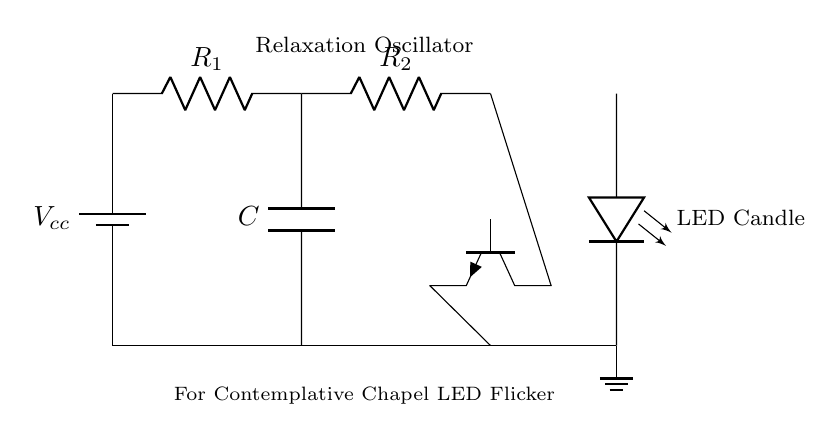What type of oscillator is depicted in the circuit? The circuit is a relaxation oscillator, which commonly uses a capacitor and a transistor to generate a non-sinusoidal waveform for effects like flickering.
Answer: relaxation oscillator What is the main purpose of this circuit in the chapel? The primary function is to control LED flicker effects, creating a calming and contemplative atmosphere appropriate for a chapel setting.
Answer: LED flicker effects How many resistors are present in the circuit? There are two resistors indicated in the circuit labeled R1 and R2, which help set the charging and discharging times of the capacitor connected in the oscillator.
Answer: 2 What component is used to create the flickering effect? The LED is responsible for producing the visible flickering effect as it lights up and turns off in a non-uniform manner.
Answer: LED Explain how the capacitor influences the flickering effect. The capacitor in the circuit charges and discharges over time, controlling the rate of current flowing to the LED. As it charges, the LED gradually brightens, and as it discharges, the LED dims, creating a flickering light pattern.
Answer: Charges and discharges What is the power supply voltage in this circuit? The circuit diagram indicates a voltage source labeled Vcc, which powers the entire circuit. The specific voltage value is not displayed, but it is implied to be sufficient for operation.
Answer: Vcc What role does the transistor play in this circuit? The transistor functions as a switch or amplifier that helps control the current from the capacitor to the LED, allowing for the flicker effect to be generated.
Answer: Switch/Amplifier 